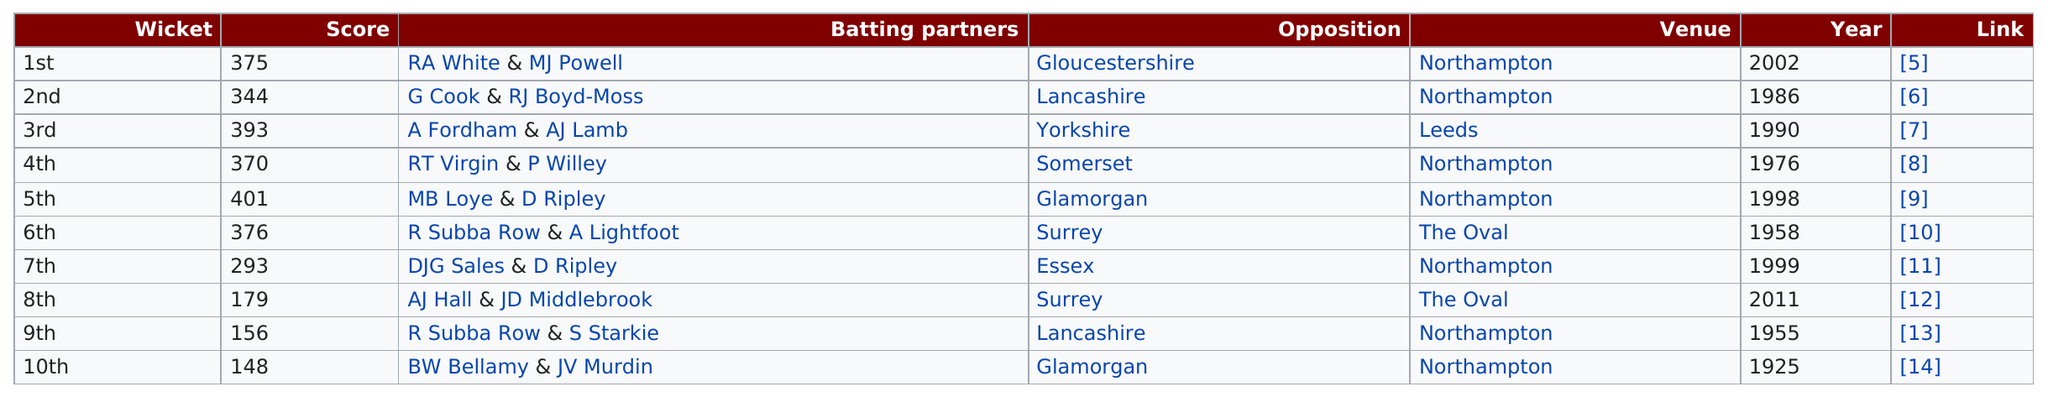Identify some key points in this picture. The last record was set in 2011. There are three venues listed. 